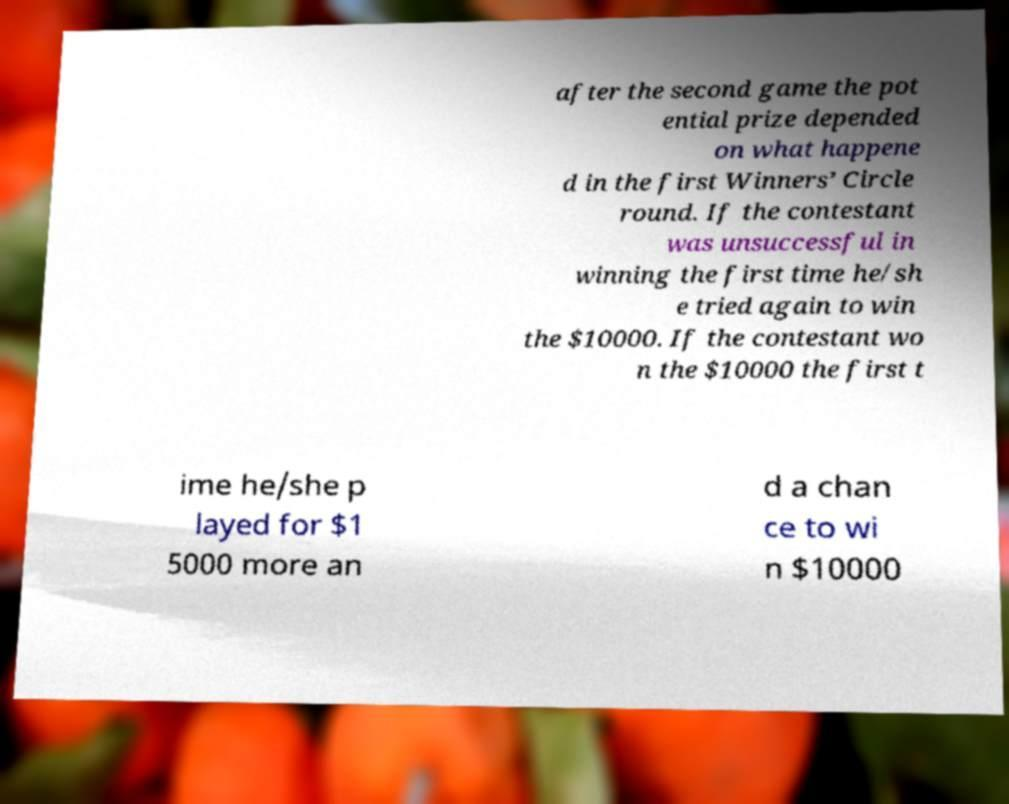For documentation purposes, I need the text within this image transcribed. Could you provide that? after the second game the pot ential prize depended on what happene d in the first Winners’ Circle round. If the contestant was unsuccessful in winning the first time he/sh e tried again to win the $10000. If the contestant wo n the $10000 the first t ime he/she p layed for $1 5000 more an d a chan ce to wi n $10000 